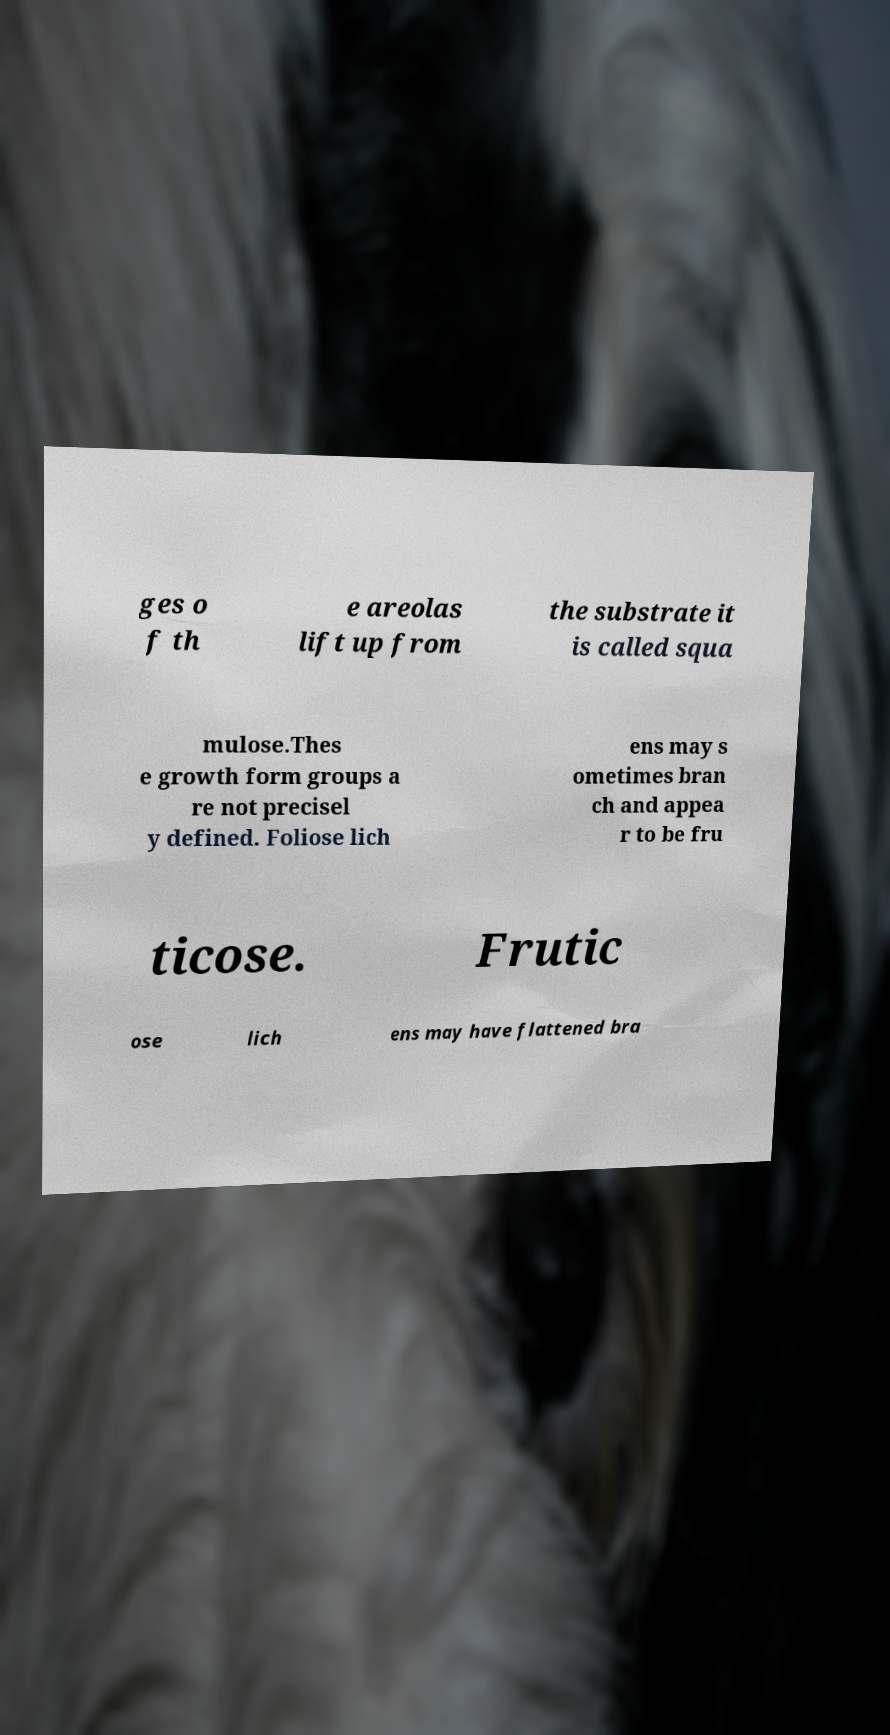Can you accurately transcribe the text from the provided image for me? ges o f th e areolas lift up from the substrate it is called squa mulose.Thes e growth form groups a re not precisel y defined. Foliose lich ens may s ometimes bran ch and appea r to be fru ticose. Frutic ose lich ens may have flattened bra 